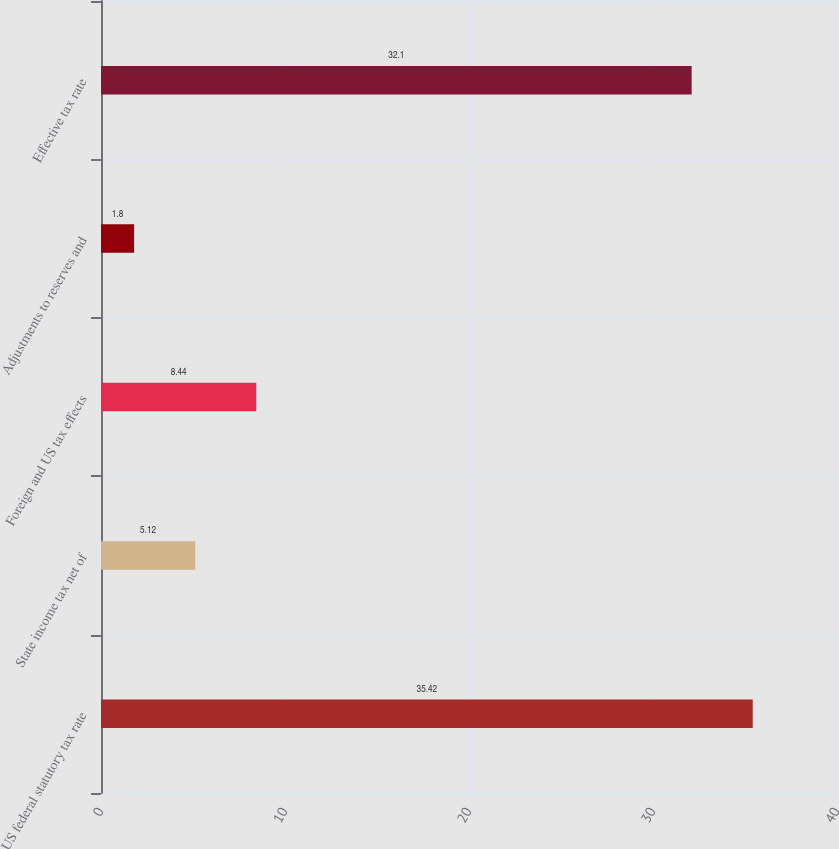Convert chart. <chart><loc_0><loc_0><loc_500><loc_500><bar_chart><fcel>US federal statutory tax rate<fcel>State income tax net of<fcel>Foreign and US tax effects<fcel>Adjustments to reserves and<fcel>Effective tax rate<nl><fcel>35.42<fcel>5.12<fcel>8.44<fcel>1.8<fcel>32.1<nl></chart> 